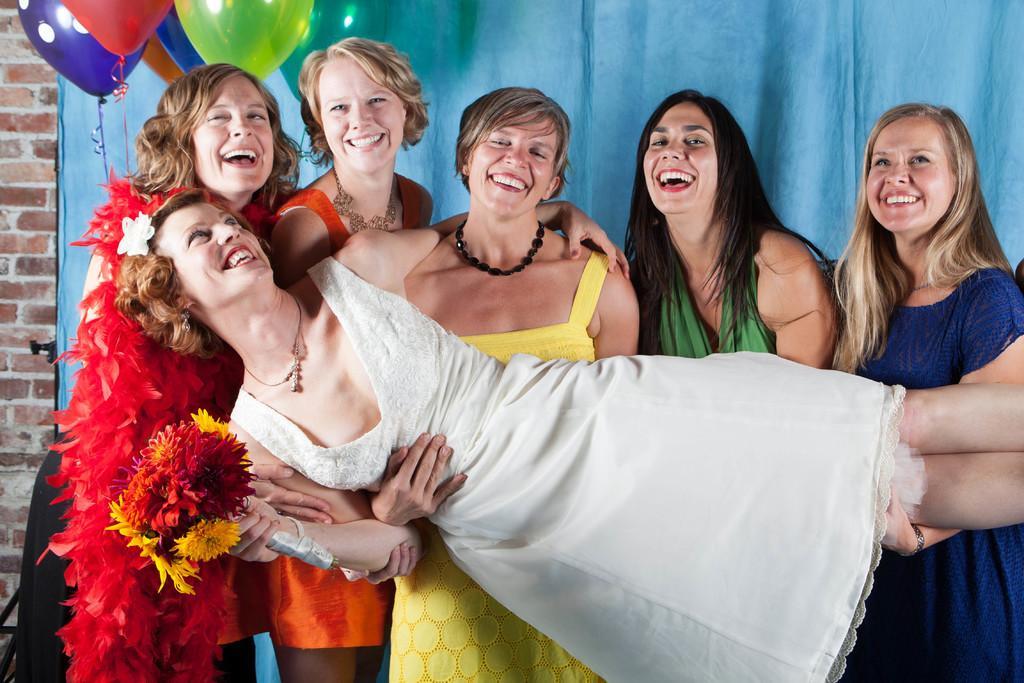In one or two sentences, can you explain what this image depicts? In this picture I can see the woman who is wearing white dress and holding the flower. Behind her I can see five women who are holding her. Everyone is laughing and standing near to the blue color cloth. In the top left corner I can see the balloons which are placed near to the brick wall. 